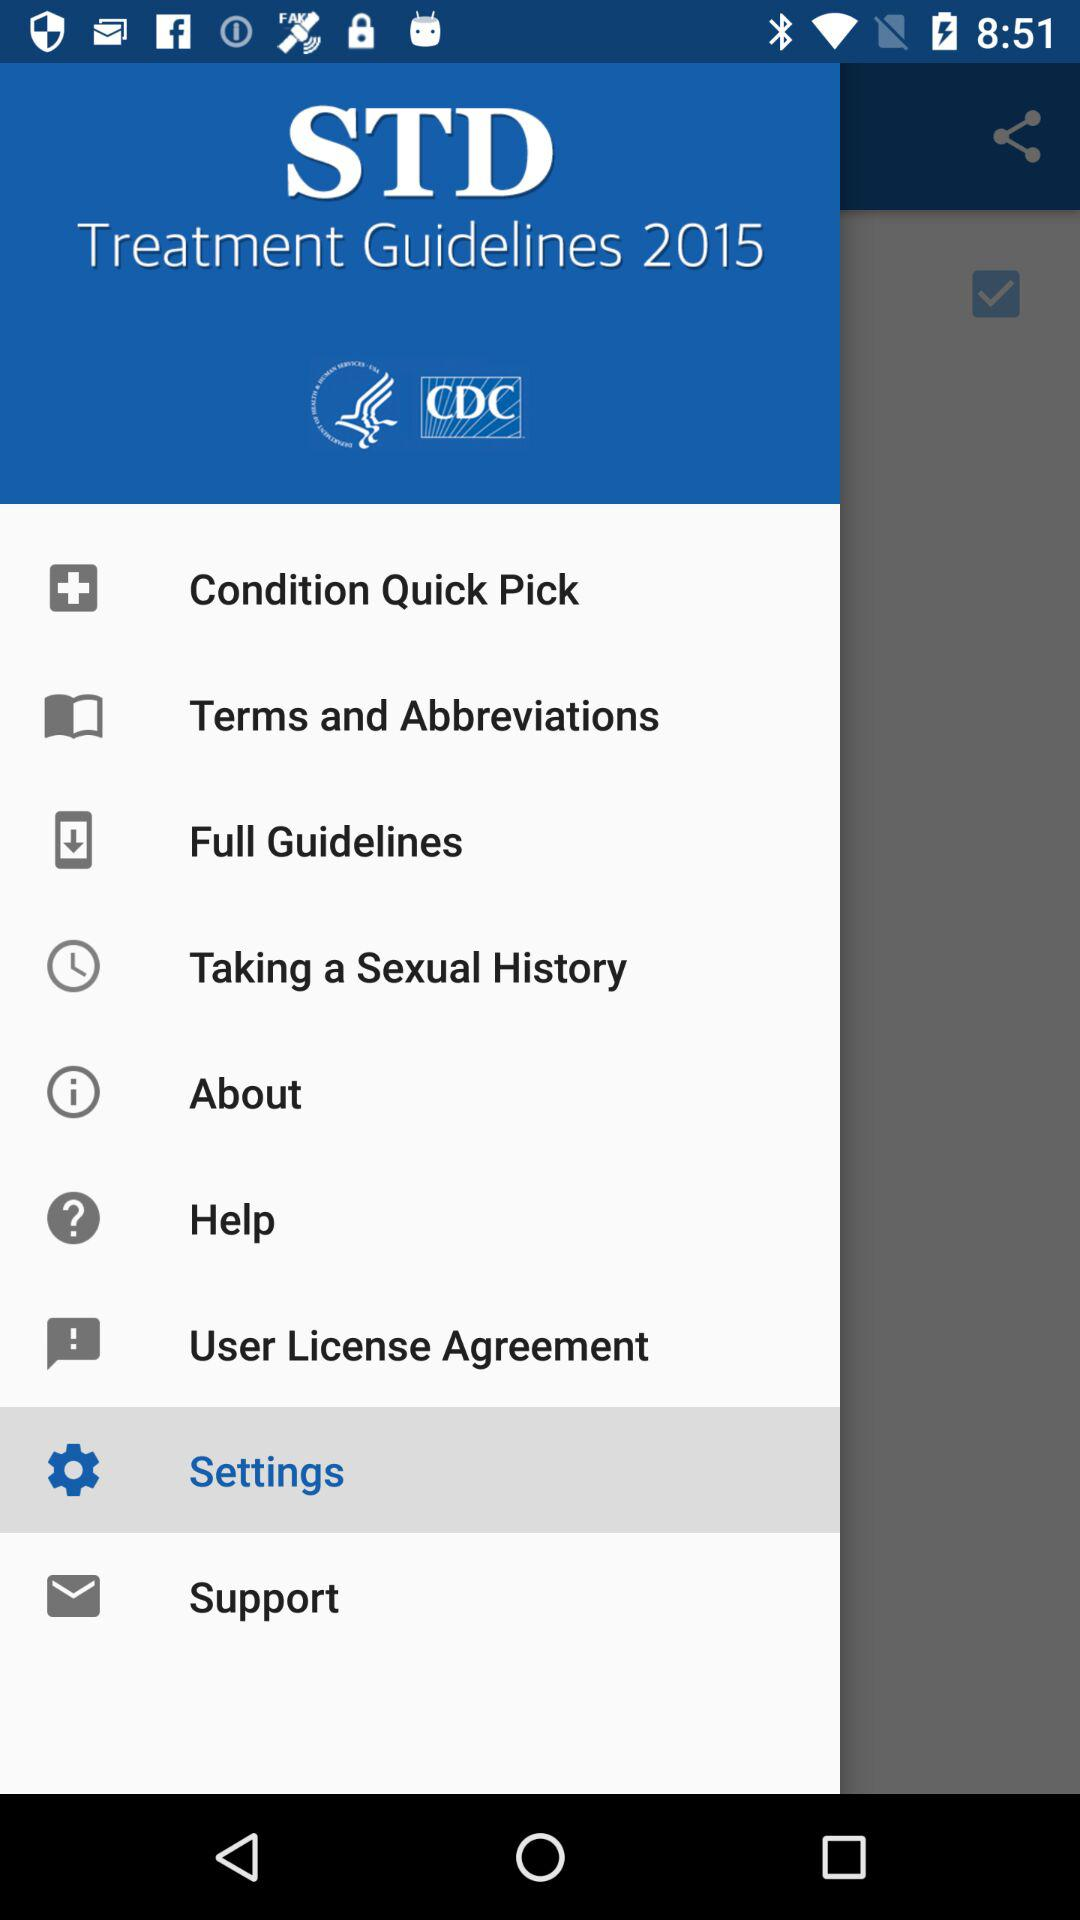What is the selected item in the menu? The selected item is "Settings". 